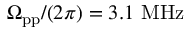Convert formula to latex. <formula><loc_0><loc_0><loc_500><loc_500>\Omega _ { p p } / ( 2 \pi ) = 3 . 1 M H z</formula> 